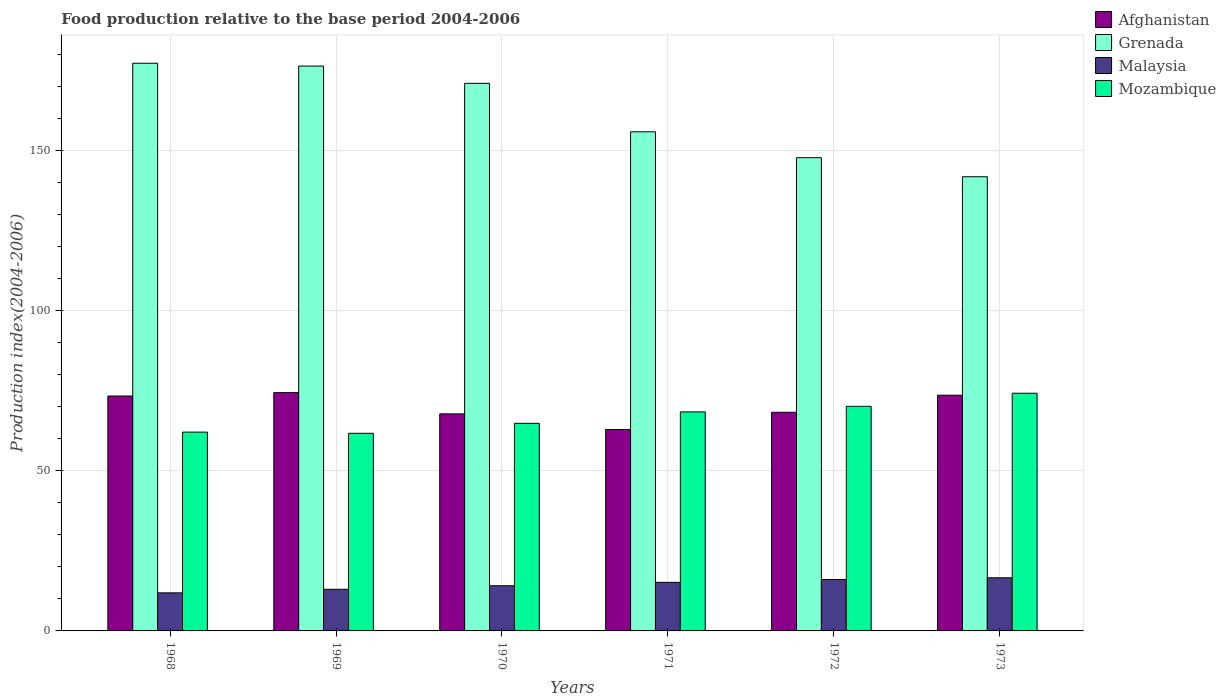How many different coloured bars are there?
Make the answer very short. 4. How many bars are there on the 5th tick from the right?
Ensure brevity in your answer.  4. In how many cases, is the number of bars for a given year not equal to the number of legend labels?
Ensure brevity in your answer.  0. What is the food production index in Malaysia in 1972?
Keep it short and to the point. 16.05. Across all years, what is the maximum food production index in Afghanistan?
Offer a very short reply. 74.37. Across all years, what is the minimum food production index in Mozambique?
Your response must be concise. 61.67. In which year was the food production index in Mozambique maximum?
Your response must be concise. 1973. In which year was the food production index in Mozambique minimum?
Make the answer very short. 1969. What is the total food production index in Malaysia in the graph?
Provide a succinct answer. 86.76. What is the difference between the food production index in Grenada in 1969 and that in 1970?
Offer a terse response. 5.39. What is the difference between the food production index in Mozambique in 1969 and the food production index in Afghanistan in 1972?
Offer a very short reply. -6.56. What is the average food production index in Afghanistan per year?
Offer a very short reply. 70.01. In the year 1968, what is the difference between the food production index in Afghanistan and food production index in Mozambique?
Your answer should be very brief. 11.27. In how many years, is the food production index in Malaysia greater than 70?
Provide a succinct answer. 0. What is the ratio of the food production index in Afghanistan in 1969 to that in 1970?
Your answer should be compact. 1.1. Is the food production index in Afghanistan in 1969 less than that in 1970?
Make the answer very short. No. What is the difference between the highest and the second highest food production index in Afghanistan?
Offer a terse response. 0.81. What is the difference between the highest and the lowest food production index in Malaysia?
Ensure brevity in your answer.  4.7. Is the sum of the food production index in Malaysia in 1968 and 1971 greater than the maximum food production index in Mozambique across all years?
Provide a short and direct response. No. What does the 2nd bar from the left in 1972 represents?
Make the answer very short. Grenada. What does the 3rd bar from the right in 1972 represents?
Ensure brevity in your answer.  Grenada. Are all the bars in the graph horizontal?
Provide a short and direct response. No. Are the values on the major ticks of Y-axis written in scientific E-notation?
Provide a short and direct response. No. How are the legend labels stacked?
Ensure brevity in your answer.  Vertical. What is the title of the graph?
Your answer should be compact. Food production relative to the base period 2004-2006. Does "Fiji" appear as one of the legend labels in the graph?
Make the answer very short. No. What is the label or title of the Y-axis?
Give a very brief answer. Production index(2004-2006). What is the Production index(2004-2006) in Afghanistan in 1968?
Ensure brevity in your answer.  73.31. What is the Production index(2004-2006) of Grenada in 1968?
Offer a terse response. 177.15. What is the Production index(2004-2006) of Malaysia in 1968?
Your response must be concise. 11.88. What is the Production index(2004-2006) of Mozambique in 1968?
Make the answer very short. 62.04. What is the Production index(2004-2006) of Afghanistan in 1969?
Your response must be concise. 74.37. What is the Production index(2004-2006) of Grenada in 1969?
Give a very brief answer. 176.27. What is the Production index(2004-2006) in Malaysia in 1969?
Your response must be concise. 12.99. What is the Production index(2004-2006) of Mozambique in 1969?
Give a very brief answer. 61.67. What is the Production index(2004-2006) of Afghanistan in 1970?
Make the answer very short. 67.73. What is the Production index(2004-2006) of Grenada in 1970?
Ensure brevity in your answer.  170.88. What is the Production index(2004-2006) of Malaysia in 1970?
Your answer should be compact. 14.1. What is the Production index(2004-2006) in Mozambique in 1970?
Your answer should be very brief. 64.78. What is the Production index(2004-2006) in Afghanistan in 1971?
Your response must be concise. 62.86. What is the Production index(2004-2006) of Grenada in 1971?
Your answer should be compact. 155.76. What is the Production index(2004-2006) of Malaysia in 1971?
Make the answer very short. 15.16. What is the Production index(2004-2006) of Mozambique in 1971?
Offer a terse response. 68.35. What is the Production index(2004-2006) in Afghanistan in 1972?
Your response must be concise. 68.23. What is the Production index(2004-2006) of Grenada in 1972?
Offer a very short reply. 147.68. What is the Production index(2004-2006) of Malaysia in 1972?
Give a very brief answer. 16.05. What is the Production index(2004-2006) of Mozambique in 1972?
Provide a short and direct response. 70.09. What is the Production index(2004-2006) of Afghanistan in 1973?
Your answer should be very brief. 73.56. What is the Production index(2004-2006) in Grenada in 1973?
Offer a terse response. 141.73. What is the Production index(2004-2006) in Malaysia in 1973?
Give a very brief answer. 16.58. What is the Production index(2004-2006) in Mozambique in 1973?
Provide a short and direct response. 74.17. Across all years, what is the maximum Production index(2004-2006) in Afghanistan?
Ensure brevity in your answer.  74.37. Across all years, what is the maximum Production index(2004-2006) in Grenada?
Your answer should be very brief. 177.15. Across all years, what is the maximum Production index(2004-2006) of Malaysia?
Your answer should be very brief. 16.58. Across all years, what is the maximum Production index(2004-2006) in Mozambique?
Offer a very short reply. 74.17. Across all years, what is the minimum Production index(2004-2006) of Afghanistan?
Keep it short and to the point. 62.86. Across all years, what is the minimum Production index(2004-2006) in Grenada?
Provide a short and direct response. 141.73. Across all years, what is the minimum Production index(2004-2006) of Malaysia?
Ensure brevity in your answer.  11.88. Across all years, what is the minimum Production index(2004-2006) in Mozambique?
Your answer should be very brief. 61.67. What is the total Production index(2004-2006) of Afghanistan in the graph?
Your answer should be very brief. 420.06. What is the total Production index(2004-2006) in Grenada in the graph?
Offer a terse response. 969.47. What is the total Production index(2004-2006) of Malaysia in the graph?
Offer a very short reply. 86.76. What is the total Production index(2004-2006) of Mozambique in the graph?
Provide a short and direct response. 401.1. What is the difference between the Production index(2004-2006) in Afghanistan in 1968 and that in 1969?
Provide a short and direct response. -1.06. What is the difference between the Production index(2004-2006) of Grenada in 1968 and that in 1969?
Give a very brief answer. 0.88. What is the difference between the Production index(2004-2006) of Malaysia in 1968 and that in 1969?
Offer a terse response. -1.11. What is the difference between the Production index(2004-2006) in Mozambique in 1968 and that in 1969?
Give a very brief answer. 0.37. What is the difference between the Production index(2004-2006) of Afghanistan in 1968 and that in 1970?
Your answer should be very brief. 5.58. What is the difference between the Production index(2004-2006) in Grenada in 1968 and that in 1970?
Give a very brief answer. 6.27. What is the difference between the Production index(2004-2006) in Malaysia in 1968 and that in 1970?
Keep it short and to the point. -2.22. What is the difference between the Production index(2004-2006) in Mozambique in 1968 and that in 1970?
Your answer should be compact. -2.74. What is the difference between the Production index(2004-2006) in Afghanistan in 1968 and that in 1971?
Ensure brevity in your answer.  10.45. What is the difference between the Production index(2004-2006) in Grenada in 1968 and that in 1971?
Ensure brevity in your answer.  21.39. What is the difference between the Production index(2004-2006) of Malaysia in 1968 and that in 1971?
Provide a short and direct response. -3.28. What is the difference between the Production index(2004-2006) in Mozambique in 1968 and that in 1971?
Offer a terse response. -6.31. What is the difference between the Production index(2004-2006) of Afghanistan in 1968 and that in 1972?
Your response must be concise. 5.08. What is the difference between the Production index(2004-2006) in Grenada in 1968 and that in 1972?
Your response must be concise. 29.47. What is the difference between the Production index(2004-2006) in Malaysia in 1968 and that in 1972?
Your answer should be compact. -4.17. What is the difference between the Production index(2004-2006) in Mozambique in 1968 and that in 1972?
Your answer should be compact. -8.05. What is the difference between the Production index(2004-2006) in Grenada in 1968 and that in 1973?
Offer a very short reply. 35.42. What is the difference between the Production index(2004-2006) in Mozambique in 1968 and that in 1973?
Keep it short and to the point. -12.13. What is the difference between the Production index(2004-2006) in Afghanistan in 1969 and that in 1970?
Ensure brevity in your answer.  6.64. What is the difference between the Production index(2004-2006) of Grenada in 1969 and that in 1970?
Ensure brevity in your answer.  5.39. What is the difference between the Production index(2004-2006) in Malaysia in 1969 and that in 1970?
Keep it short and to the point. -1.11. What is the difference between the Production index(2004-2006) in Mozambique in 1969 and that in 1970?
Give a very brief answer. -3.11. What is the difference between the Production index(2004-2006) in Afghanistan in 1969 and that in 1971?
Your answer should be compact. 11.51. What is the difference between the Production index(2004-2006) in Grenada in 1969 and that in 1971?
Provide a succinct answer. 20.51. What is the difference between the Production index(2004-2006) of Malaysia in 1969 and that in 1971?
Ensure brevity in your answer.  -2.17. What is the difference between the Production index(2004-2006) of Mozambique in 1969 and that in 1971?
Your answer should be very brief. -6.68. What is the difference between the Production index(2004-2006) in Afghanistan in 1969 and that in 1972?
Ensure brevity in your answer.  6.14. What is the difference between the Production index(2004-2006) in Grenada in 1969 and that in 1972?
Keep it short and to the point. 28.59. What is the difference between the Production index(2004-2006) of Malaysia in 1969 and that in 1972?
Provide a succinct answer. -3.06. What is the difference between the Production index(2004-2006) of Mozambique in 1969 and that in 1972?
Keep it short and to the point. -8.42. What is the difference between the Production index(2004-2006) of Afghanistan in 1969 and that in 1973?
Offer a very short reply. 0.81. What is the difference between the Production index(2004-2006) of Grenada in 1969 and that in 1973?
Ensure brevity in your answer.  34.54. What is the difference between the Production index(2004-2006) in Malaysia in 1969 and that in 1973?
Make the answer very short. -3.59. What is the difference between the Production index(2004-2006) of Afghanistan in 1970 and that in 1971?
Ensure brevity in your answer.  4.87. What is the difference between the Production index(2004-2006) in Grenada in 1970 and that in 1971?
Your response must be concise. 15.12. What is the difference between the Production index(2004-2006) in Malaysia in 1970 and that in 1971?
Make the answer very short. -1.06. What is the difference between the Production index(2004-2006) of Mozambique in 1970 and that in 1971?
Give a very brief answer. -3.57. What is the difference between the Production index(2004-2006) of Grenada in 1970 and that in 1972?
Offer a terse response. 23.2. What is the difference between the Production index(2004-2006) of Malaysia in 1970 and that in 1972?
Ensure brevity in your answer.  -1.95. What is the difference between the Production index(2004-2006) in Mozambique in 1970 and that in 1972?
Provide a short and direct response. -5.31. What is the difference between the Production index(2004-2006) in Afghanistan in 1970 and that in 1973?
Ensure brevity in your answer.  -5.83. What is the difference between the Production index(2004-2006) in Grenada in 1970 and that in 1973?
Your answer should be very brief. 29.15. What is the difference between the Production index(2004-2006) of Malaysia in 1970 and that in 1973?
Your answer should be very brief. -2.48. What is the difference between the Production index(2004-2006) in Mozambique in 1970 and that in 1973?
Ensure brevity in your answer.  -9.39. What is the difference between the Production index(2004-2006) in Afghanistan in 1971 and that in 1972?
Provide a succinct answer. -5.37. What is the difference between the Production index(2004-2006) of Grenada in 1971 and that in 1972?
Make the answer very short. 8.08. What is the difference between the Production index(2004-2006) of Malaysia in 1971 and that in 1972?
Your answer should be compact. -0.89. What is the difference between the Production index(2004-2006) in Mozambique in 1971 and that in 1972?
Give a very brief answer. -1.74. What is the difference between the Production index(2004-2006) in Afghanistan in 1971 and that in 1973?
Your answer should be very brief. -10.7. What is the difference between the Production index(2004-2006) in Grenada in 1971 and that in 1973?
Your answer should be compact. 14.03. What is the difference between the Production index(2004-2006) of Malaysia in 1971 and that in 1973?
Offer a very short reply. -1.42. What is the difference between the Production index(2004-2006) of Mozambique in 1971 and that in 1973?
Your answer should be very brief. -5.82. What is the difference between the Production index(2004-2006) of Afghanistan in 1972 and that in 1973?
Provide a succinct answer. -5.33. What is the difference between the Production index(2004-2006) in Grenada in 1972 and that in 1973?
Give a very brief answer. 5.95. What is the difference between the Production index(2004-2006) of Malaysia in 1972 and that in 1973?
Give a very brief answer. -0.53. What is the difference between the Production index(2004-2006) of Mozambique in 1972 and that in 1973?
Ensure brevity in your answer.  -4.08. What is the difference between the Production index(2004-2006) in Afghanistan in 1968 and the Production index(2004-2006) in Grenada in 1969?
Give a very brief answer. -102.96. What is the difference between the Production index(2004-2006) of Afghanistan in 1968 and the Production index(2004-2006) of Malaysia in 1969?
Your answer should be compact. 60.32. What is the difference between the Production index(2004-2006) in Afghanistan in 1968 and the Production index(2004-2006) in Mozambique in 1969?
Make the answer very short. 11.64. What is the difference between the Production index(2004-2006) of Grenada in 1968 and the Production index(2004-2006) of Malaysia in 1969?
Provide a succinct answer. 164.16. What is the difference between the Production index(2004-2006) of Grenada in 1968 and the Production index(2004-2006) of Mozambique in 1969?
Provide a succinct answer. 115.48. What is the difference between the Production index(2004-2006) in Malaysia in 1968 and the Production index(2004-2006) in Mozambique in 1969?
Make the answer very short. -49.79. What is the difference between the Production index(2004-2006) in Afghanistan in 1968 and the Production index(2004-2006) in Grenada in 1970?
Keep it short and to the point. -97.57. What is the difference between the Production index(2004-2006) in Afghanistan in 1968 and the Production index(2004-2006) in Malaysia in 1970?
Offer a terse response. 59.21. What is the difference between the Production index(2004-2006) of Afghanistan in 1968 and the Production index(2004-2006) of Mozambique in 1970?
Give a very brief answer. 8.53. What is the difference between the Production index(2004-2006) of Grenada in 1968 and the Production index(2004-2006) of Malaysia in 1970?
Make the answer very short. 163.05. What is the difference between the Production index(2004-2006) in Grenada in 1968 and the Production index(2004-2006) in Mozambique in 1970?
Give a very brief answer. 112.37. What is the difference between the Production index(2004-2006) in Malaysia in 1968 and the Production index(2004-2006) in Mozambique in 1970?
Give a very brief answer. -52.9. What is the difference between the Production index(2004-2006) in Afghanistan in 1968 and the Production index(2004-2006) in Grenada in 1971?
Provide a short and direct response. -82.45. What is the difference between the Production index(2004-2006) of Afghanistan in 1968 and the Production index(2004-2006) of Malaysia in 1971?
Provide a succinct answer. 58.15. What is the difference between the Production index(2004-2006) in Afghanistan in 1968 and the Production index(2004-2006) in Mozambique in 1971?
Offer a very short reply. 4.96. What is the difference between the Production index(2004-2006) of Grenada in 1968 and the Production index(2004-2006) of Malaysia in 1971?
Offer a very short reply. 161.99. What is the difference between the Production index(2004-2006) in Grenada in 1968 and the Production index(2004-2006) in Mozambique in 1971?
Offer a terse response. 108.8. What is the difference between the Production index(2004-2006) of Malaysia in 1968 and the Production index(2004-2006) of Mozambique in 1971?
Provide a short and direct response. -56.47. What is the difference between the Production index(2004-2006) of Afghanistan in 1968 and the Production index(2004-2006) of Grenada in 1972?
Make the answer very short. -74.37. What is the difference between the Production index(2004-2006) in Afghanistan in 1968 and the Production index(2004-2006) in Malaysia in 1972?
Your answer should be very brief. 57.26. What is the difference between the Production index(2004-2006) of Afghanistan in 1968 and the Production index(2004-2006) of Mozambique in 1972?
Keep it short and to the point. 3.22. What is the difference between the Production index(2004-2006) in Grenada in 1968 and the Production index(2004-2006) in Malaysia in 1972?
Make the answer very short. 161.1. What is the difference between the Production index(2004-2006) of Grenada in 1968 and the Production index(2004-2006) of Mozambique in 1972?
Your answer should be compact. 107.06. What is the difference between the Production index(2004-2006) in Malaysia in 1968 and the Production index(2004-2006) in Mozambique in 1972?
Your answer should be very brief. -58.21. What is the difference between the Production index(2004-2006) in Afghanistan in 1968 and the Production index(2004-2006) in Grenada in 1973?
Offer a terse response. -68.42. What is the difference between the Production index(2004-2006) in Afghanistan in 1968 and the Production index(2004-2006) in Malaysia in 1973?
Provide a short and direct response. 56.73. What is the difference between the Production index(2004-2006) in Afghanistan in 1968 and the Production index(2004-2006) in Mozambique in 1973?
Give a very brief answer. -0.86. What is the difference between the Production index(2004-2006) in Grenada in 1968 and the Production index(2004-2006) in Malaysia in 1973?
Your answer should be very brief. 160.57. What is the difference between the Production index(2004-2006) in Grenada in 1968 and the Production index(2004-2006) in Mozambique in 1973?
Your answer should be compact. 102.98. What is the difference between the Production index(2004-2006) in Malaysia in 1968 and the Production index(2004-2006) in Mozambique in 1973?
Your response must be concise. -62.29. What is the difference between the Production index(2004-2006) of Afghanistan in 1969 and the Production index(2004-2006) of Grenada in 1970?
Keep it short and to the point. -96.51. What is the difference between the Production index(2004-2006) in Afghanistan in 1969 and the Production index(2004-2006) in Malaysia in 1970?
Make the answer very short. 60.27. What is the difference between the Production index(2004-2006) in Afghanistan in 1969 and the Production index(2004-2006) in Mozambique in 1970?
Make the answer very short. 9.59. What is the difference between the Production index(2004-2006) in Grenada in 1969 and the Production index(2004-2006) in Malaysia in 1970?
Provide a short and direct response. 162.17. What is the difference between the Production index(2004-2006) of Grenada in 1969 and the Production index(2004-2006) of Mozambique in 1970?
Keep it short and to the point. 111.49. What is the difference between the Production index(2004-2006) in Malaysia in 1969 and the Production index(2004-2006) in Mozambique in 1970?
Offer a terse response. -51.79. What is the difference between the Production index(2004-2006) of Afghanistan in 1969 and the Production index(2004-2006) of Grenada in 1971?
Your answer should be very brief. -81.39. What is the difference between the Production index(2004-2006) in Afghanistan in 1969 and the Production index(2004-2006) in Malaysia in 1971?
Make the answer very short. 59.21. What is the difference between the Production index(2004-2006) in Afghanistan in 1969 and the Production index(2004-2006) in Mozambique in 1971?
Offer a very short reply. 6.02. What is the difference between the Production index(2004-2006) in Grenada in 1969 and the Production index(2004-2006) in Malaysia in 1971?
Offer a terse response. 161.11. What is the difference between the Production index(2004-2006) of Grenada in 1969 and the Production index(2004-2006) of Mozambique in 1971?
Ensure brevity in your answer.  107.92. What is the difference between the Production index(2004-2006) in Malaysia in 1969 and the Production index(2004-2006) in Mozambique in 1971?
Give a very brief answer. -55.36. What is the difference between the Production index(2004-2006) of Afghanistan in 1969 and the Production index(2004-2006) of Grenada in 1972?
Your answer should be compact. -73.31. What is the difference between the Production index(2004-2006) in Afghanistan in 1969 and the Production index(2004-2006) in Malaysia in 1972?
Give a very brief answer. 58.32. What is the difference between the Production index(2004-2006) in Afghanistan in 1969 and the Production index(2004-2006) in Mozambique in 1972?
Provide a succinct answer. 4.28. What is the difference between the Production index(2004-2006) in Grenada in 1969 and the Production index(2004-2006) in Malaysia in 1972?
Offer a terse response. 160.22. What is the difference between the Production index(2004-2006) in Grenada in 1969 and the Production index(2004-2006) in Mozambique in 1972?
Ensure brevity in your answer.  106.18. What is the difference between the Production index(2004-2006) in Malaysia in 1969 and the Production index(2004-2006) in Mozambique in 1972?
Keep it short and to the point. -57.1. What is the difference between the Production index(2004-2006) of Afghanistan in 1969 and the Production index(2004-2006) of Grenada in 1973?
Offer a terse response. -67.36. What is the difference between the Production index(2004-2006) in Afghanistan in 1969 and the Production index(2004-2006) in Malaysia in 1973?
Offer a terse response. 57.79. What is the difference between the Production index(2004-2006) of Grenada in 1969 and the Production index(2004-2006) of Malaysia in 1973?
Offer a very short reply. 159.69. What is the difference between the Production index(2004-2006) in Grenada in 1969 and the Production index(2004-2006) in Mozambique in 1973?
Provide a succinct answer. 102.1. What is the difference between the Production index(2004-2006) in Malaysia in 1969 and the Production index(2004-2006) in Mozambique in 1973?
Offer a terse response. -61.18. What is the difference between the Production index(2004-2006) in Afghanistan in 1970 and the Production index(2004-2006) in Grenada in 1971?
Your response must be concise. -88.03. What is the difference between the Production index(2004-2006) in Afghanistan in 1970 and the Production index(2004-2006) in Malaysia in 1971?
Offer a very short reply. 52.57. What is the difference between the Production index(2004-2006) in Afghanistan in 1970 and the Production index(2004-2006) in Mozambique in 1971?
Provide a short and direct response. -0.62. What is the difference between the Production index(2004-2006) of Grenada in 1970 and the Production index(2004-2006) of Malaysia in 1971?
Give a very brief answer. 155.72. What is the difference between the Production index(2004-2006) of Grenada in 1970 and the Production index(2004-2006) of Mozambique in 1971?
Offer a terse response. 102.53. What is the difference between the Production index(2004-2006) in Malaysia in 1970 and the Production index(2004-2006) in Mozambique in 1971?
Give a very brief answer. -54.25. What is the difference between the Production index(2004-2006) of Afghanistan in 1970 and the Production index(2004-2006) of Grenada in 1972?
Your response must be concise. -79.95. What is the difference between the Production index(2004-2006) of Afghanistan in 1970 and the Production index(2004-2006) of Malaysia in 1972?
Offer a terse response. 51.68. What is the difference between the Production index(2004-2006) in Afghanistan in 1970 and the Production index(2004-2006) in Mozambique in 1972?
Your response must be concise. -2.36. What is the difference between the Production index(2004-2006) in Grenada in 1970 and the Production index(2004-2006) in Malaysia in 1972?
Make the answer very short. 154.83. What is the difference between the Production index(2004-2006) in Grenada in 1970 and the Production index(2004-2006) in Mozambique in 1972?
Make the answer very short. 100.79. What is the difference between the Production index(2004-2006) of Malaysia in 1970 and the Production index(2004-2006) of Mozambique in 1972?
Provide a short and direct response. -55.99. What is the difference between the Production index(2004-2006) in Afghanistan in 1970 and the Production index(2004-2006) in Grenada in 1973?
Your answer should be very brief. -74. What is the difference between the Production index(2004-2006) of Afghanistan in 1970 and the Production index(2004-2006) of Malaysia in 1973?
Keep it short and to the point. 51.15. What is the difference between the Production index(2004-2006) of Afghanistan in 1970 and the Production index(2004-2006) of Mozambique in 1973?
Ensure brevity in your answer.  -6.44. What is the difference between the Production index(2004-2006) in Grenada in 1970 and the Production index(2004-2006) in Malaysia in 1973?
Keep it short and to the point. 154.3. What is the difference between the Production index(2004-2006) in Grenada in 1970 and the Production index(2004-2006) in Mozambique in 1973?
Provide a short and direct response. 96.71. What is the difference between the Production index(2004-2006) in Malaysia in 1970 and the Production index(2004-2006) in Mozambique in 1973?
Your answer should be compact. -60.07. What is the difference between the Production index(2004-2006) of Afghanistan in 1971 and the Production index(2004-2006) of Grenada in 1972?
Your answer should be very brief. -84.82. What is the difference between the Production index(2004-2006) in Afghanistan in 1971 and the Production index(2004-2006) in Malaysia in 1972?
Your answer should be compact. 46.81. What is the difference between the Production index(2004-2006) of Afghanistan in 1971 and the Production index(2004-2006) of Mozambique in 1972?
Keep it short and to the point. -7.23. What is the difference between the Production index(2004-2006) of Grenada in 1971 and the Production index(2004-2006) of Malaysia in 1972?
Your answer should be compact. 139.71. What is the difference between the Production index(2004-2006) in Grenada in 1971 and the Production index(2004-2006) in Mozambique in 1972?
Offer a terse response. 85.67. What is the difference between the Production index(2004-2006) of Malaysia in 1971 and the Production index(2004-2006) of Mozambique in 1972?
Keep it short and to the point. -54.93. What is the difference between the Production index(2004-2006) in Afghanistan in 1971 and the Production index(2004-2006) in Grenada in 1973?
Offer a terse response. -78.87. What is the difference between the Production index(2004-2006) in Afghanistan in 1971 and the Production index(2004-2006) in Malaysia in 1973?
Provide a succinct answer. 46.28. What is the difference between the Production index(2004-2006) of Afghanistan in 1971 and the Production index(2004-2006) of Mozambique in 1973?
Make the answer very short. -11.31. What is the difference between the Production index(2004-2006) of Grenada in 1971 and the Production index(2004-2006) of Malaysia in 1973?
Offer a very short reply. 139.18. What is the difference between the Production index(2004-2006) in Grenada in 1971 and the Production index(2004-2006) in Mozambique in 1973?
Make the answer very short. 81.59. What is the difference between the Production index(2004-2006) in Malaysia in 1971 and the Production index(2004-2006) in Mozambique in 1973?
Your answer should be very brief. -59.01. What is the difference between the Production index(2004-2006) in Afghanistan in 1972 and the Production index(2004-2006) in Grenada in 1973?
Ensure brevity in your answer.  -73.5. What is the difference between the Production index(2004-2006) in Afghanistan in 1972 and the Production index(2004-2006) in Malaysia in 1973?
Provide a succinct answer. 51.65. What is the difference between the Production index(2004-2006) in Afghanistan in 1972 and the Production index(2004-2006) in Mozambique in 1973?
Your answer should be very brief. -5.94. What is the difference between the Production index(2004-2006) of Grenada in 1972 and the Production index(2004-2006) of Malaysia in 1973?
Provide a short and direct response. 131.1. What is the difference between the Production index(2004-2006) of Grenada in 1972 and the Production index(2004-2006) of Mozambique in 1973?
Your response must be concise. 73.51. What is the difference between the Production index(2004-2006) in Malaysia in 1972 and the Production index(2004-2006) in Mozambique in 1973?
Your answer should be very brief. -58.12. What is the average Production index(2004-2006) in Afghanistan per year?
Ensure brevity in your answer.  70.01. What is the average Production index(2004-2006) of Grenada per year?
Make the answer very short. 161.58. What is the average Production index(2004-2006) of Malaysia per year?
Give a very brief answer. 14.46. What is the average Production index(2004-2006) of Mozambique per year?
Keep it short and to the point. 66.85. In the year 1968, what is the difference between the Production index(2004-2006) of Afghanistan and Production index(2004-2006) of Grenada?
Ensure brevity in your answer.  -103.84. In the year 1968, what is the difference between the Production index(2004-2006) in Afghanistan and Production index(2004-2006) in Malaysia?
Provide a short and direct response. 61.43. In the year 1968, what is the difference between the Production index(2004-2006) of Afghanistan and Production index(2004-2006) of Mozambique?
Make the answer very short. 11.27. In the year 1968, what is the difference between the Production index(2004-2006) of Grenada and Production index(2004-2006) of Malaysia?
Provide a short and direct response. 165.27. In the year 1968, what is the difference between the Production index(2004-2006) in Grenada and Production index(2004-2006) in Mozambique?
Provide a succinct answer. 115.11. In the year 1968, what is the difference between the Production index(2004-2006) in Malaysia and Production index(2004-2006) in Mozambique?
Offer a very short reply. -50.16. In the year 1969, what is the difference between the Production index(2004-2006) of Afghanistan and Production index(2004-2006) of Grenada?
Give a very brief answer. -101.9. In the year 1969, what is the difference between the Production index(2004-2006) of Afghanistan and Production index(2004-2006) of Malaysia?
Give a very brief answer. 61.38. In the year 1969, what is the difference between the Production index(2004-2006) in Afghanistan and Production index(2004-2006) in Mozambique?
Give a very brief answer. 12.7. In the year 1969, what is the difference between the Production index(2004-2006) of Grenada and Production index(2004-2006) of Malaysia?
Give a very brief answer. 163.28. In the year 1969, what is the difference between the Production index(2004-2006) in Grenada and Production index(2004-2006) in Mozambique?
Your answer should be compact. 114.6. In the year 1969, what is the difference between the Production index(2004-2006) of Malaysia and Production index(2004-2006) of Mozambique?
Give a very brief answer. -48.68. In the year 1970, what is the difference between the Production index(2004-2006) of Afghanistan and Production index(2004-2006) of Grenada?
Provide a short and direct response. -103.15. In the year 1970, what is the difference between the Production index(2004-2006) in Afghanistan and Production index(2004-2006) in Malaysia?
Make the answer very short. 53.63. In the year 1970, what is the difference between the Production index(2004-2006) of Afghanistan and Production index(2004-2006) of Mozambique?
Offer a terse response. 2.95. In the year 1970, what is the difference between the Production index(2004-2006) in Grenada and Production index(2004-2006) in Malaysia?
Ensure brevity in your answer.  156.78. In the year 1970, what is the difference between the Production index(2004-2006) of Grenada and Production index(2004-2006) of Mozambique?
Offer a very short reply. 106.1. In the year 1970, what is the difference between the Production index(2004-2006) in Malaysia and Production index(2004-2006) in Mozambique?
Your answer should be very brief. -50.68. In the year 1971, what is the difference between the Production index(2004-2006) in Afghanistan and Production index(2004-2006) in Grenada?
Provide a short and direct response. -92.9. In the year 1971, what is the difference between the Production index(2004-2006) in Afghanistan and Production index(2004-2006) in Malaysia?
Give a very brief answer. 47.7. In the year 1971, what is the difference between the Production index(2004-2006) in Afghanistan and Production index(2004-2006) in Mozambique?
Your response must be concise. -5.49. In the year 1971, what is the difference between the Production index(2004-2006) of Grenada and Production index(2004-2006) of Malaysia?
Keep it short and to the point. 140.6. In the year 1971, what is the difference between the Production index(2004-2006) in Grenada and Production index(2004-2006) in Mozambique?
Offer a terse response. 87.41. In the year 1971, what is the difference between the Production index(2004-2006) in Malaysia and Production index(2004-2006) in Mozambique?
Provide a short and direct response. -53.19. In the year 1972, what is the difference between the Production index(2004-2006) of Afghanistan and Production index(2004-2006) of Grenada?
Provide a succinct answer. -79.45. In the year 1972, what is the difference between the Production index(2004-2006) of Afghanistan and Production index(2004-2006) of Malaysia?
Your response must be concise. 52.18. In the year 1972, what is the difference between the Production index(2004-2006) in Afghanistan and Production index(2004-2006) in Mozambique?
Keep it short and to the point. -1.86. In the year 1972, what is the difference between the Production index(2004-2006) of Grenada and Production index(2004-2006) of Malaysia?
Provide a succinct answer. 131.63. In the year 1972, what is the difference between the Production index(2004-2006) of Grenada and Production index(2004-2006) of Mozambique?
Offer a terse response. 77.59. In the year 1972, what is the difference between the Production index(2004-2006) in Malaysia and Production index(2004-2006) in Mozambique?
Give a very brief answer. -54.04. In the year 1973, what is the difference between the Production index(2004-2006) of Afghanistan and Production index(2004-2006) of Grenada?
Ensure brevity in your answer.  -68.17. In the year 1973, what is the difference between the Production index(2004-2006) in Afghanistan and Production index(2004-2006) in Malaysia?
Your answer should be compact. 56.98. In the year 1973, what is the difference between the Production index(2004-2006) of Afghanistan and Production index(2004-2006) of Mozambique?
Ensure brevity in your answer.  -0.61. In the year 1973, what is the difference between the Production index(2004-2006) in Grenada and Production index(2004-2006) in Malaysia?
Provide a succinct answer. 125.15. In the year 1973, what is the difference between the Production index(2004-2006) of Grenada and Production index(2004-2006) of Mozambique?
Provide a succinct answer. 67.56. In the year 1973, what is the difference between the Production index(2004-2006) in Malaysia and Production index(2004-2006) in Mozambique?
Keep it short and to the point. -57.59. What is the ratio of the Production index(2004-2006) of Afghanistan in 1968 to that in 1969?
Your response must be concise. 0.99. What is the ratio of the Production index(2004-2006) of Malaysia in 1968 to that in 1969?
Ensure brevity in your answer.  0.91. What is the ratio of the Production index(2004-2006) of Mozambique in 1968 to that in 1969?
Your response must be concise. 1.01. What is the ratio of the Production index(2004-2006) of Afghanistan in 1968 to that in 1970?
Ensure brevity in your answer.  1.08. What is the ratio of the Production index(2004-2006) of Grenada in 1968 to that in 1970?
Your answer should be very brief. 1.04. What is the ratio of the Production index(2004-2006) of Malaysia in 1968 to that in 1970?
Ensure brevity in your answer.  0.84. What is the ratio of the Production index(2004-2006) in Mozambique in 1968 to that in 1970?
Your answer should be very brief. 0.96. What is the ratio of the Production index(2004-2006) in Afghanistan in 1968 to that in 1971?
Give a very brief answer. 1.17. What is the ratio of the Production index(2004-2006) in Grenada in 1968 to that in 1971?
Provide a short and direct response. 1.14. What is the ratio of the Production index(2004-2006) in Malaysia in 1968 to that in 1971?
Keep it short and to the point. 0.78. What is the ratio of the Production index(2004-2006) of Mozambique in 1968 to that in 1971?
Your answer should be compact. 0.91. What is the ratio of the Production index(2004-2006) in Afghanistan in 1968 to that in 1972?
Keep it short and to the point. 1.07. What is the ratio of the Production index(2004-2006) in Grenada in 1968 to that in 1972?
Offer a very short reply. 1.2. What is the ratio of the Production index(2004-2006) in Malaysia in 1968 to that in 1972?
Your answer should be compact. 0.74. What is the ratio of the Production index(2004-2006) in Mozambique in 1968 to that in 1972?
Ensure brevity in your answer.  0.89. What is the ratio of the Production index(2004-2006) in Grenada in 1968 to that in 1973?
Provide a succinct answer. 1.25. What is the ratio of the Production index(2004-2006) in Malaysia in 1968 to that in 1973?
Ensure brevity in your answer.  0.72. What is the ratio of the Production index(2004-2006) of Mozambique in 1968 to that in 1973?
Offer a terse response. 0.84. What is the ratio of the Production index(2004-2006) in Afghanistan in 1969 to that in 1970?
Ensure brevity in your answer.  1.1. What is the ratio of the Production index(2004-2006) in Grenada in 1969 to that in 1970?
Offer a terse response. 1.03. What is the ratio of the Production index(2004-2006) of Malaysia in 1969 to that in 1970?
Offer a very short reply. 0.92. What is the ratio of the Production index(2004-2006) in Afghanistan in 1969 to that in 1971?
Offer a terse response. 1.18. What is the ratio of the Production index(2004-2006) of Grenada in 1969 to that in 1971?
Offer a terse response. 1.13. What is the ratio of the Production index(2004-2006) in Malaysia in 1969 to that in 1971?
Make the answer very short. 0.86. What is the ratio of the Production index(2004-2006) of Mozambique in 1969 to that in 1971?
Your answer should be very brief. 0.9. What is the ratio of the Production index(2004-2006) of Afghanistan in 1969 to that in 1972?
Keep it short and to the point. 1.09. What is the ratio of the Production index(2004-2006) in Grenada in 1969 to that in 1972?
Your response must be concise. 1.19. What is the ratio of the Production index(2004-2006) in Malaysia in 1969 to that in 1972?
Offer a terse response. 0.81. What is the ratio of the Production index(2004-2006) of Mozambique in 1969 to that in 1972?
Make the answer very short. 0.88. What is the ratio of the Production index(2004-2006) of Grenada in 1969 to that in 1973?
Give a very brief answer. 1.24. What is the ratio of the Production index(2004-2006) in Malaysia in 1969 to that in 1973?
Your response must be concise. 0.78. What is the ratio of the Production index(2004-2006) of Mozambique in 1969 to that in 1973?
Your answer should be compact. 0.83. What is the ratio of the Production index(2004-2006) of Afghanistan in 1970 to that in 1971?
Keep it short and to the point. 1.08. What is the ratio of the Production index(2004-2006) in Grenada in 1970 to that in 1971?
Provide a succinct answer. 1.1. What is the ratio of the Production index(2004-2006) of Malaysia in 1970 to that in 1971?
Offer a terse response. 0.93. What is the ratio of the Production index(2004-2006) in Mozambique in 1970 to that in 1971?
Offer a very short reply. 0.95. What is the ratio of the Production index(2004-2006) of Grenada in 1970 to that in 1972?
Offer a terse response. 1.16. What is the ratio of the Production index(2004-2006) of Malaysia in 1970 to that in 1972?
Keep it short and to the point. 0.88. What is the ratio of the Production index(2004-2006) in Mozambique in 1970 to that in 1972?
Your answer should be very brief. 0.92. What is the ratio of the Production index(2004-2006) in Afghanistan in 1970 to that in 1973?
Your answer should be compact. 0.92. What is the ratio of the Production index(2004-2006) of Grenada in 1970 to that in 1973?
Make the answer very short. 1.21. What is the ratio of the Production index(2004-2006) in Malaysia in 1970 to that in 1973?
Keep it short and to the point. 0.85. What is the ratio of the Production index(2004-2006) of Mozambique in 1970 to that in 1973?
Make the answer very short. 0.87. What is the ratio of the Production index(2004-2006) of Afghanistan in 1971 to that in 1972?
Ensure brevity in your answer.  0.92. What is the ratio of the Production index(2004-2006) in Grenada in 1971 to that in 1972?
Offer a very short reply. 1.05. What is the ratio of the Production index(2004-2006) of Malaysia in 1971 to that in 1972?
Offer a very short reply. 0.94. What is the ratio of the Production index(2004-2006) of Mozambique in 1971 to that in 1972?
Offer a very short reply. 0.98. What is the ratio of the Production index(2004-2006) of Afghanistan in 1971 to that in 1973?
Provide a short and direct response. 0.85. What is the ratio of the Production index(2004-2006) in Grenada in 1971 to that in 1973?
Provide a succinct answer. 1.1. What is the ratio of the Production index(2004-2006) in Malaysia in 1971 to that in 1973?
Your response must be concise. 0.91. What is the ratio of the Production index(2004-2006) of Mozambique in 1971 to that in 1973?
Provide a succinct answer. 0.92. What is the ratio of the Production index(2004-2006) in Afghanistan in 1972 to that in 1973?
Your answer should be very brief. 0.93. What is the ratio of the Production index(2004-2006) in Grenada in 1972 to that in 1973?
Offer a very short reply. 1.04. What is the ratio of the Production index(2004-2006) in Malaysia in 1972 to that in 1973?
Keep it short and to the point. 0.97. What is the ratio of the Production index(2004-2006) in Mozambique in 1972 to that in 1973?
Ensure brevity in your answer.  0.94. What is the difference between the highest and the second highest Production index(2004-2006) of Afghanistan?
Keep it short and to the point. 0.81. What is the difference between the highest and the second highest Production index(2004-2006) in Grenada?
Offer a terse response. 0.88. What is the difference between the highest and the second highest Production index(2004-2006) in Malaysia?
Keep it short and to the point. 0.53. What is the difference between the highest and the second highest Production index(2004-2006) in Mozambique?
Offer a very short reply. 4.08. What is the difference between the highest and the lowest Production index(2004-2006) of Afghanistan?
Your response must be concise. 11.51. What is the difference between the highest and the lowest Production index(2004-2006) of Grenada?
Provide a short and direct response. 35.42. What is the difference between the highest and the lowest Production index(2004-2006) of Mozambique?
Ensure brevity in your answer.  12.5. 